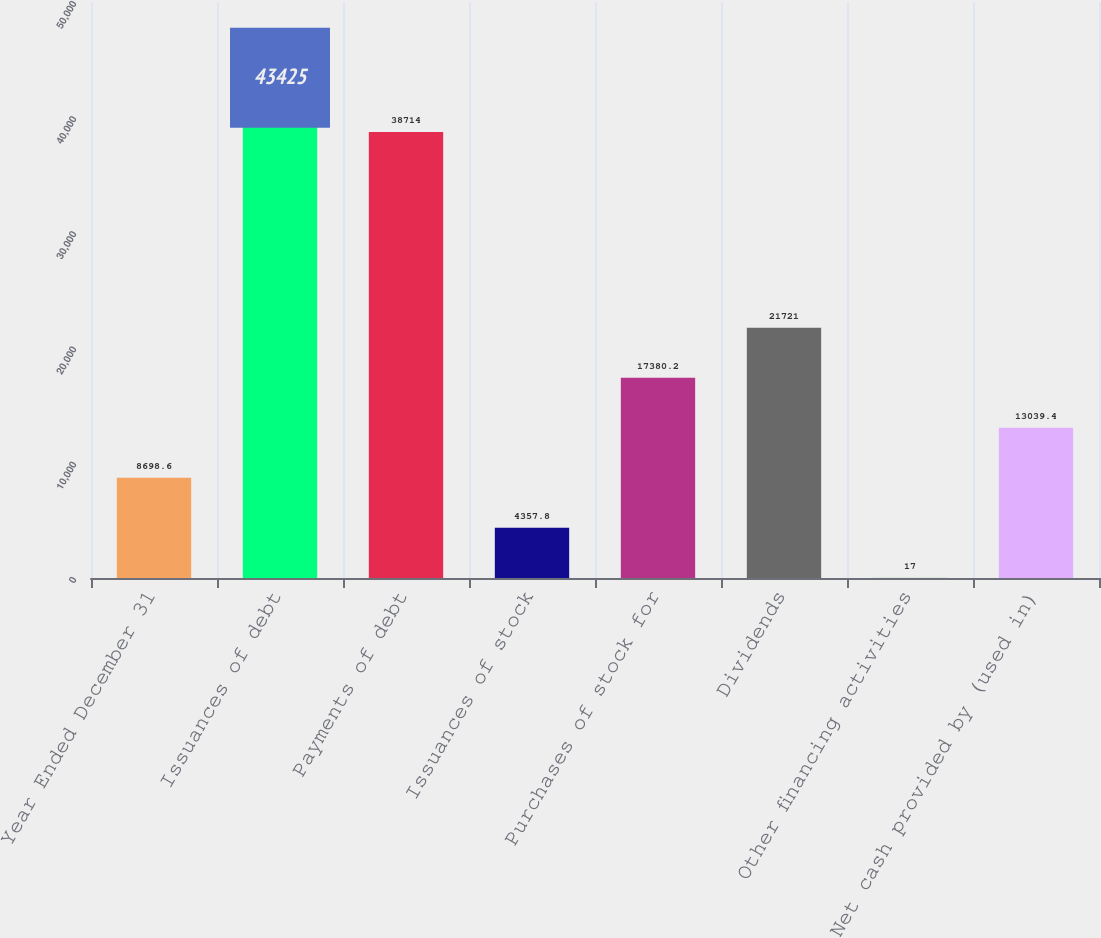Convert chart to OTSL. <chart><loc_0><loc_0><loc_500><loc_500><bar_chart><fcel>Year Ended December 31<fcel>Issuances of debt<fcel>Payments of debt<fcel>Issuances of stock<fcel>Purchases of stock for<fcel>Dividends<fcel>Other financing activities<fcel>Net cash provided by (used in)<nl><fcel>8698.6<fcel>43425<fcel>38714<fcel>4357.8<fcel>17380.2<fcel>21721<fcel>17<fcel>13039.4<nl></chart> 